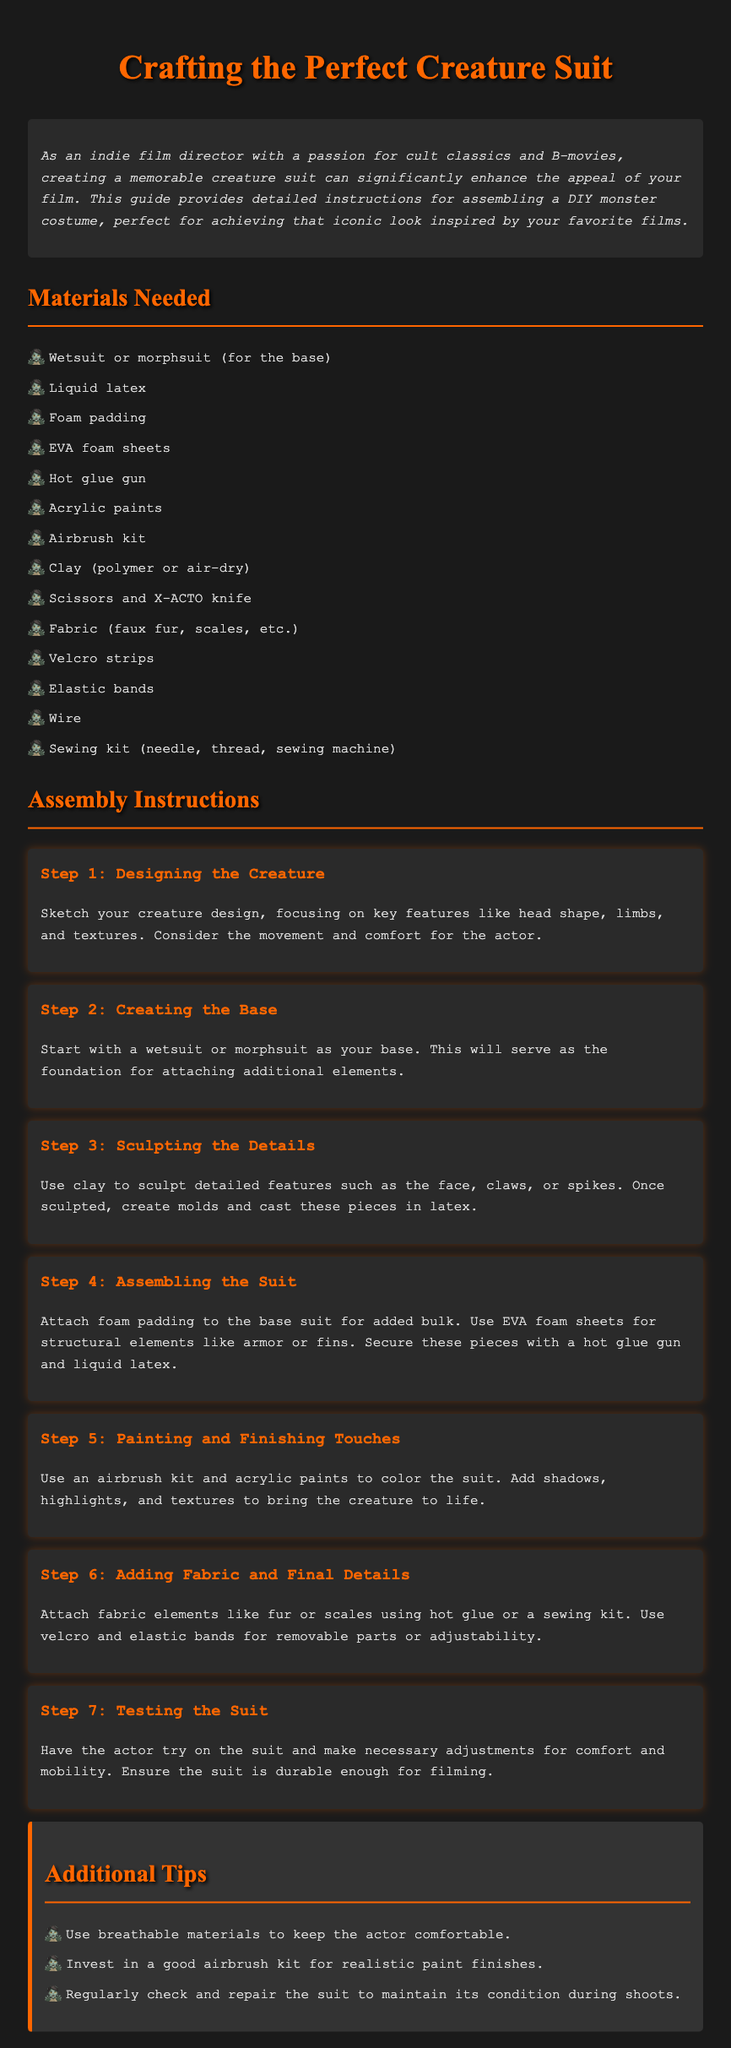What is the title of the guide? The title of the guide is prominently stated at the top of the document.
Answer: Crafting the Perfect Creature Suit How many materials are listed? The number of materials can be counted from the "Materials Needed" section in the document.
Answer: 13 What is the first step in assembling the suit? The first step is outlined in the "Assembly Instructions" section.
Answer: Designing the Creature What tool is suggested for sculpting details? The document specifies a tool to be used for detail sculpting among the materials needed.
Answer: Clay What feature is emphasized for the base suit? The document highlights a specific feature of the base suit to serve as the foundation.
Answer: Wetsuit or morphsuit What color is the text for step headings? The text color for the headings in the steps can be determined from the styling details provided in the document.
Answer: Orange What additional items are suggested for the painting process? The document mentions specific items required to enhance the painting aspect of the costume.
Answer: Airbrush kit What is advised for keeping the actor comfortable? There is a specific recommendation in the "Additional Tips" section aimed at ensuring actor comfort.
Answer: Breathable materials 